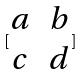Convert formula to latex. <formula><loc_0><loc_0><loc_500><loc_500>[ \begin{matrix} a & b \\ c & d \\ \end{matrix} ]</formula> 